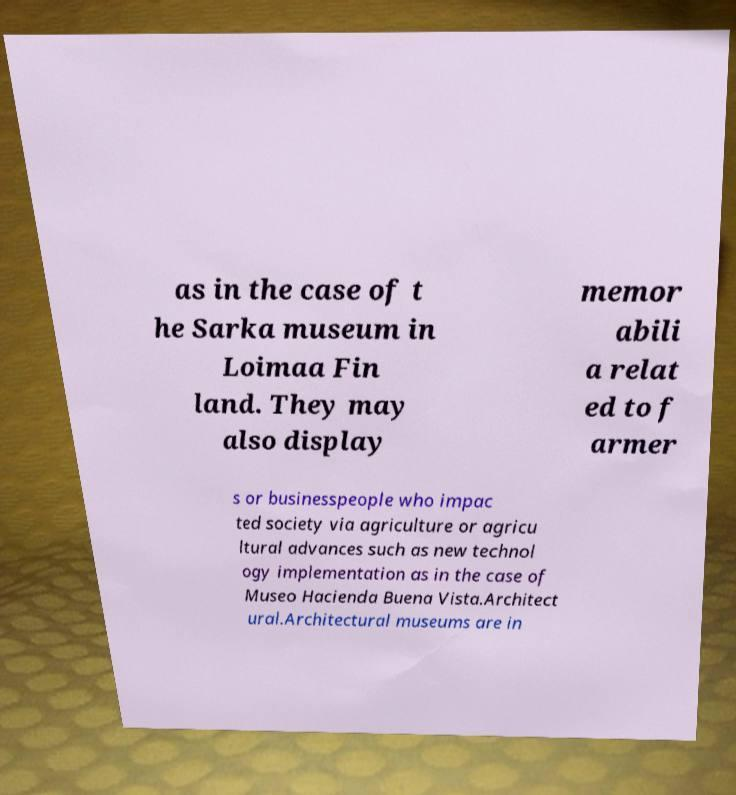Could you extract and type out the text from this image? as in the case of t he Sarka museum in Loimaa Fin land. They may also display memor abili a relat ed to f armer s or businesspeople who impac ted society via agriculture or agricu ltural advances such as new technol ogy implementation as in the case of Museo Hacienda Buena Vista.Architect ural.Architectural museums are in 